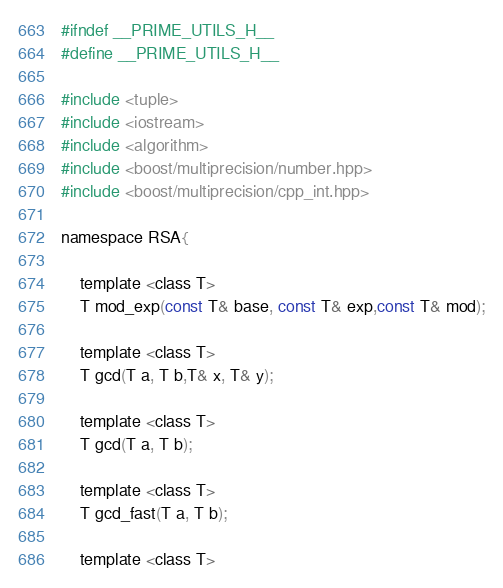<code> <loc_0><loc_0><loc_500><loc_500><_C_>#ifndef __PRIME_UTILS_H__
#define __PRIME_UTILS_H__

#include <tuple>
#include <iostream>
#include <algorithm>
#include <boost/multiprecision/number.hpp>
#include <boost/multiprecision/cpp_int.hpp>

namespace RSA{
    
    template <class T>
    T mod_exp(const T& base, const T& exp,const T& mod);

    template <class T>
    T gcd(T a, T b,T& x, T& y);

    template <class T>
    T gcd(T a, T b);

    template <class T>
    T gcd_fast(T a, T b);

    template <class T></code> 